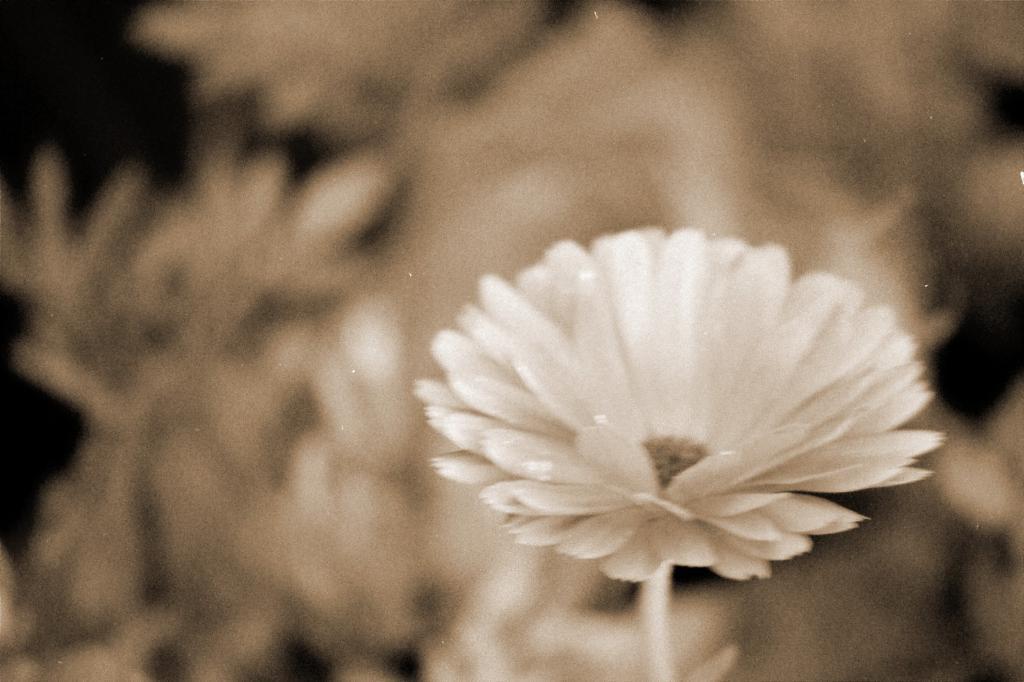Describe this image in one or two sentences. It is a black and white picture. Here we can see a flower and stem. Background we can see a blur view. 